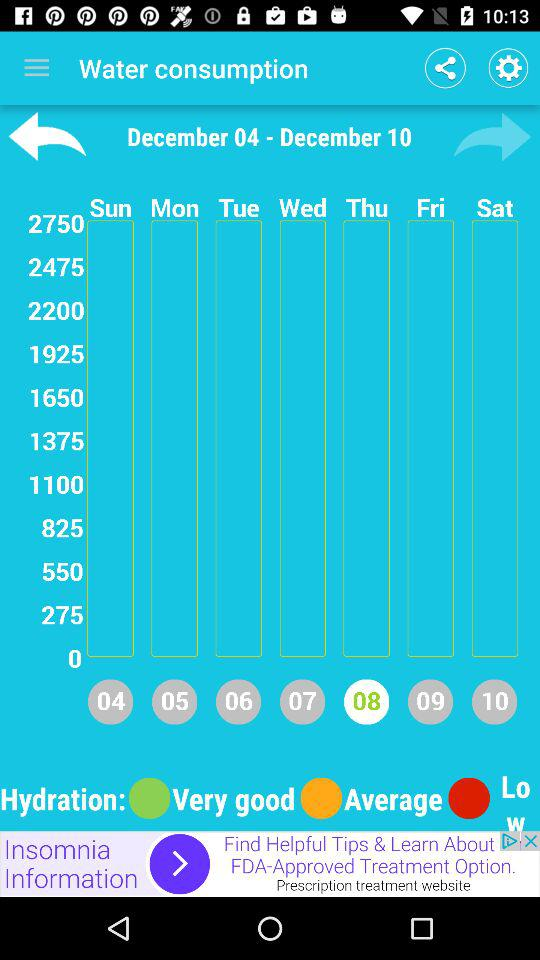What time period data is this? The time period is December 04–December 10. 